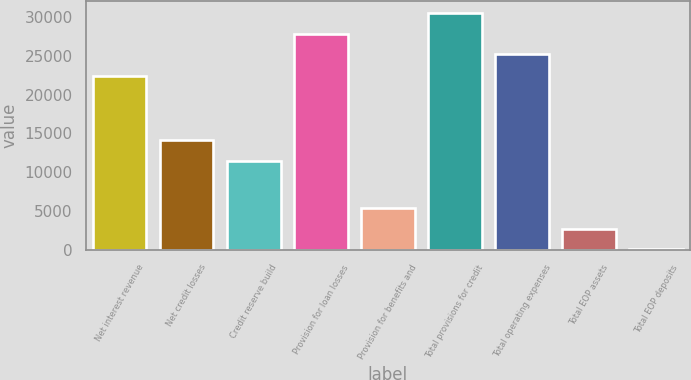Convert chart. <chart><loc_0><loc_0><loc_500><loc_500><bar_chart><fcel>Net interest revenue<fcel>Net credit losses<fcel>Credit reserve build<fcel>Provision for loan losses<fcel>Provision for benefits and<fcel>Total provisions for credit<fcel>Total operating expenses<fcel>Total EOP assets<fcel>Total EOP deposits<nl><fcel>22459<fcel>14109.5<fcel>11444<fcel>27862.5<fcel>5414<fcel>30528<fcel>25197<fcel>2748.5<fcel>83<nl></chart> 